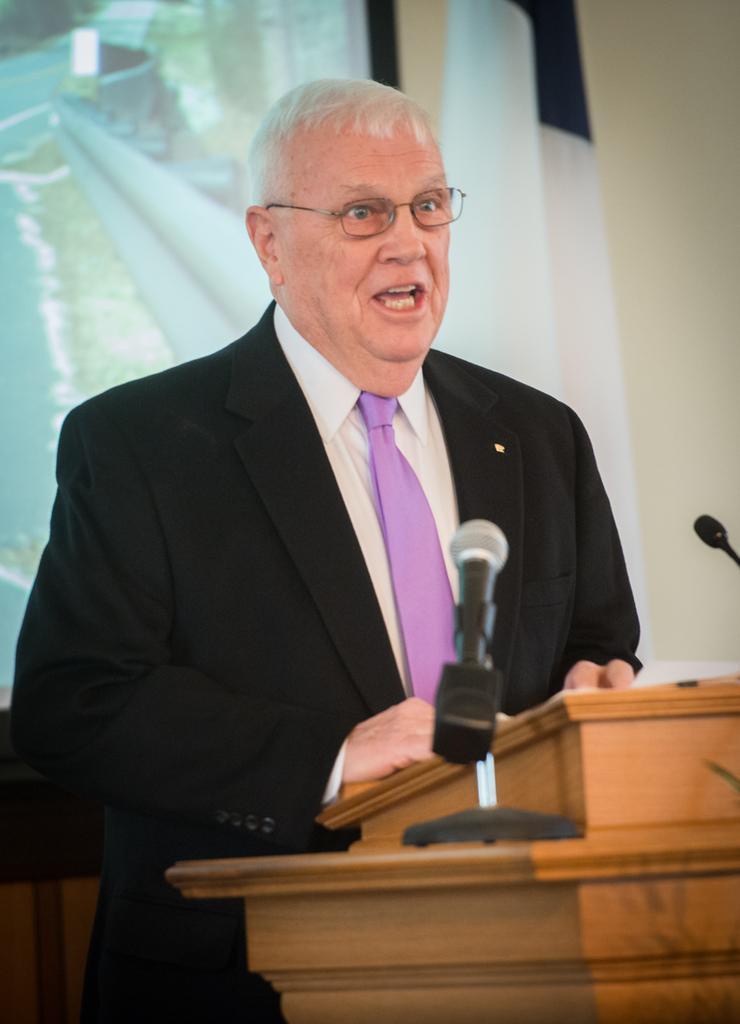Please provide a concise description of this image. In this image we can see a person wearing specs. Also there is a podium. There are mics. In the back there is a wall. Also there is a screen. 